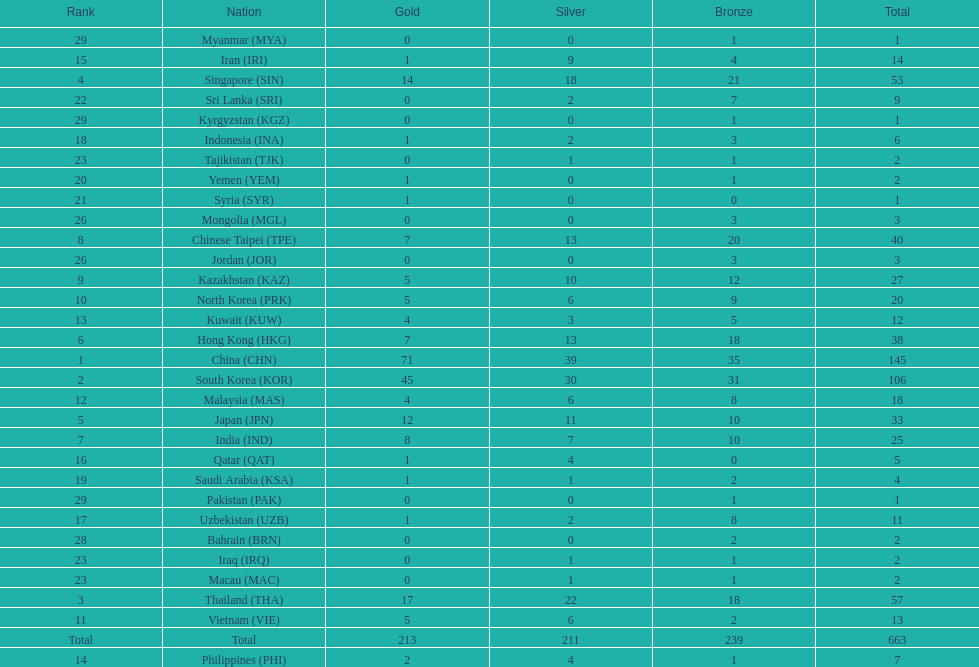What is the difference between the total amount of medals won by qatar and indonesia? 1. I'm looking to parse the entire table for insights. Could you assist me with that? {'header': ['Rank', 'Nation', 'Gold', 'Silver', 'Bronze', 'Total'], 'rows': [['29', 'Myanmar\xa0(MYA)', '0', '0', '1', '1'], ['15', 'Iran\xa0(IRI)', '1', '9', '4', '14'], ['4', 'Singapore\xa0(SIN)', '14', '18', '21', '53'], ['22', 'Sri Lanka\xa0(SRI)', '0', '2', '7', '9'], ['29', 'Kyrgyzstan\xa0(KGZ)', '0', '0', '1', '1'], ['18', 'Indonesia\xa0(INA)', '1', '2', '3', '6'], ['23', 'Tajikistan\xa0(TJK)', '0', '1', '1', '2'], ['20', 'Yemen\xa0(YEM)', '1', '0', '1', '2'], ['21', 'Syria\xa0(SYR)', '1', '0', '0', '1'], ['26', 'Mongolia\xa0(MGL)', '0', '0', '3', '3'], ['8', 'Chinese Taipei\xa0(TPE)', '7', '13', '20', '40'], ['26', 'Jordan\xa0(JOR)', '0', '0', '3', '3'], ['9', 'Kazakhstan\xa0(KAZ)', '5', '10', '12', '27'], ['10', 'North Korea\xa0(PRK)', '5', '6', '9', '20'], ['13', 'Kuwait\xa0(KUW)', '4', '3', '5', '12'], ['6', 'Hong Kong\xa0(HKG)', '7', '13', '18', '38'], ['1', 'China\xa0(CHN)', '71', '39', '35', '145'], ['2', 'South Korea\xa0(KOR)', '45', '30', '31', '106'], ['12', 'Malaysia\xa0(MAS)', '4', '6', '8', '18'], ['5', 'Japan\xa0(JPN)', '12', '11', '10', '33'], ['7', 'India\xa0(IND)', '8', '7', '10', '25'], ['16', 'Qatar\xa0(QAT)', '1', '4', '0', '5'], ['19', 'Saudi Arabia\xa0(KSA)', '1', '1', '2', '4'], ['29', 'Pakistan\xa0(PAK)', '0', '0', '1', '1'], ['17', 'Uzbekistan\xa0(UZB)', '1', '2', '8', '11'], ['28', 'Bahrain\xa0(BRN)', '0', '0', '2', '2'], ['23', 'Iraq\xa0(IRQ)', '0', '1', '1', '2'], ['23', 'Macau\xa0(MAC)', '0', '1', '1', '2'], ['3', 'Thailand\xa0(THA)', '17', '22', '18', '57'], ['11', 'Vietnam\xa0(VIE)', '5', '6', '2', '13'], ['Total', 'Total', '213', '211', '239', '663'], ['14', 'Philippines\xa0(PHI)', '2', '4', '1', '7']]} 